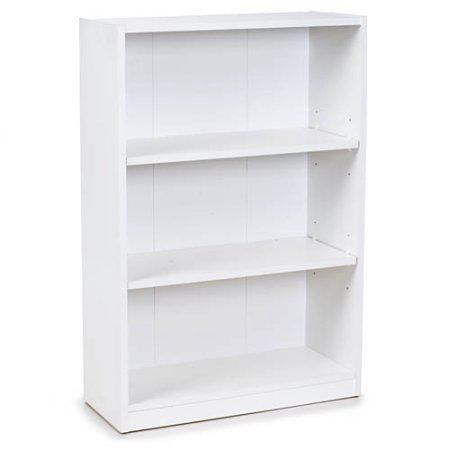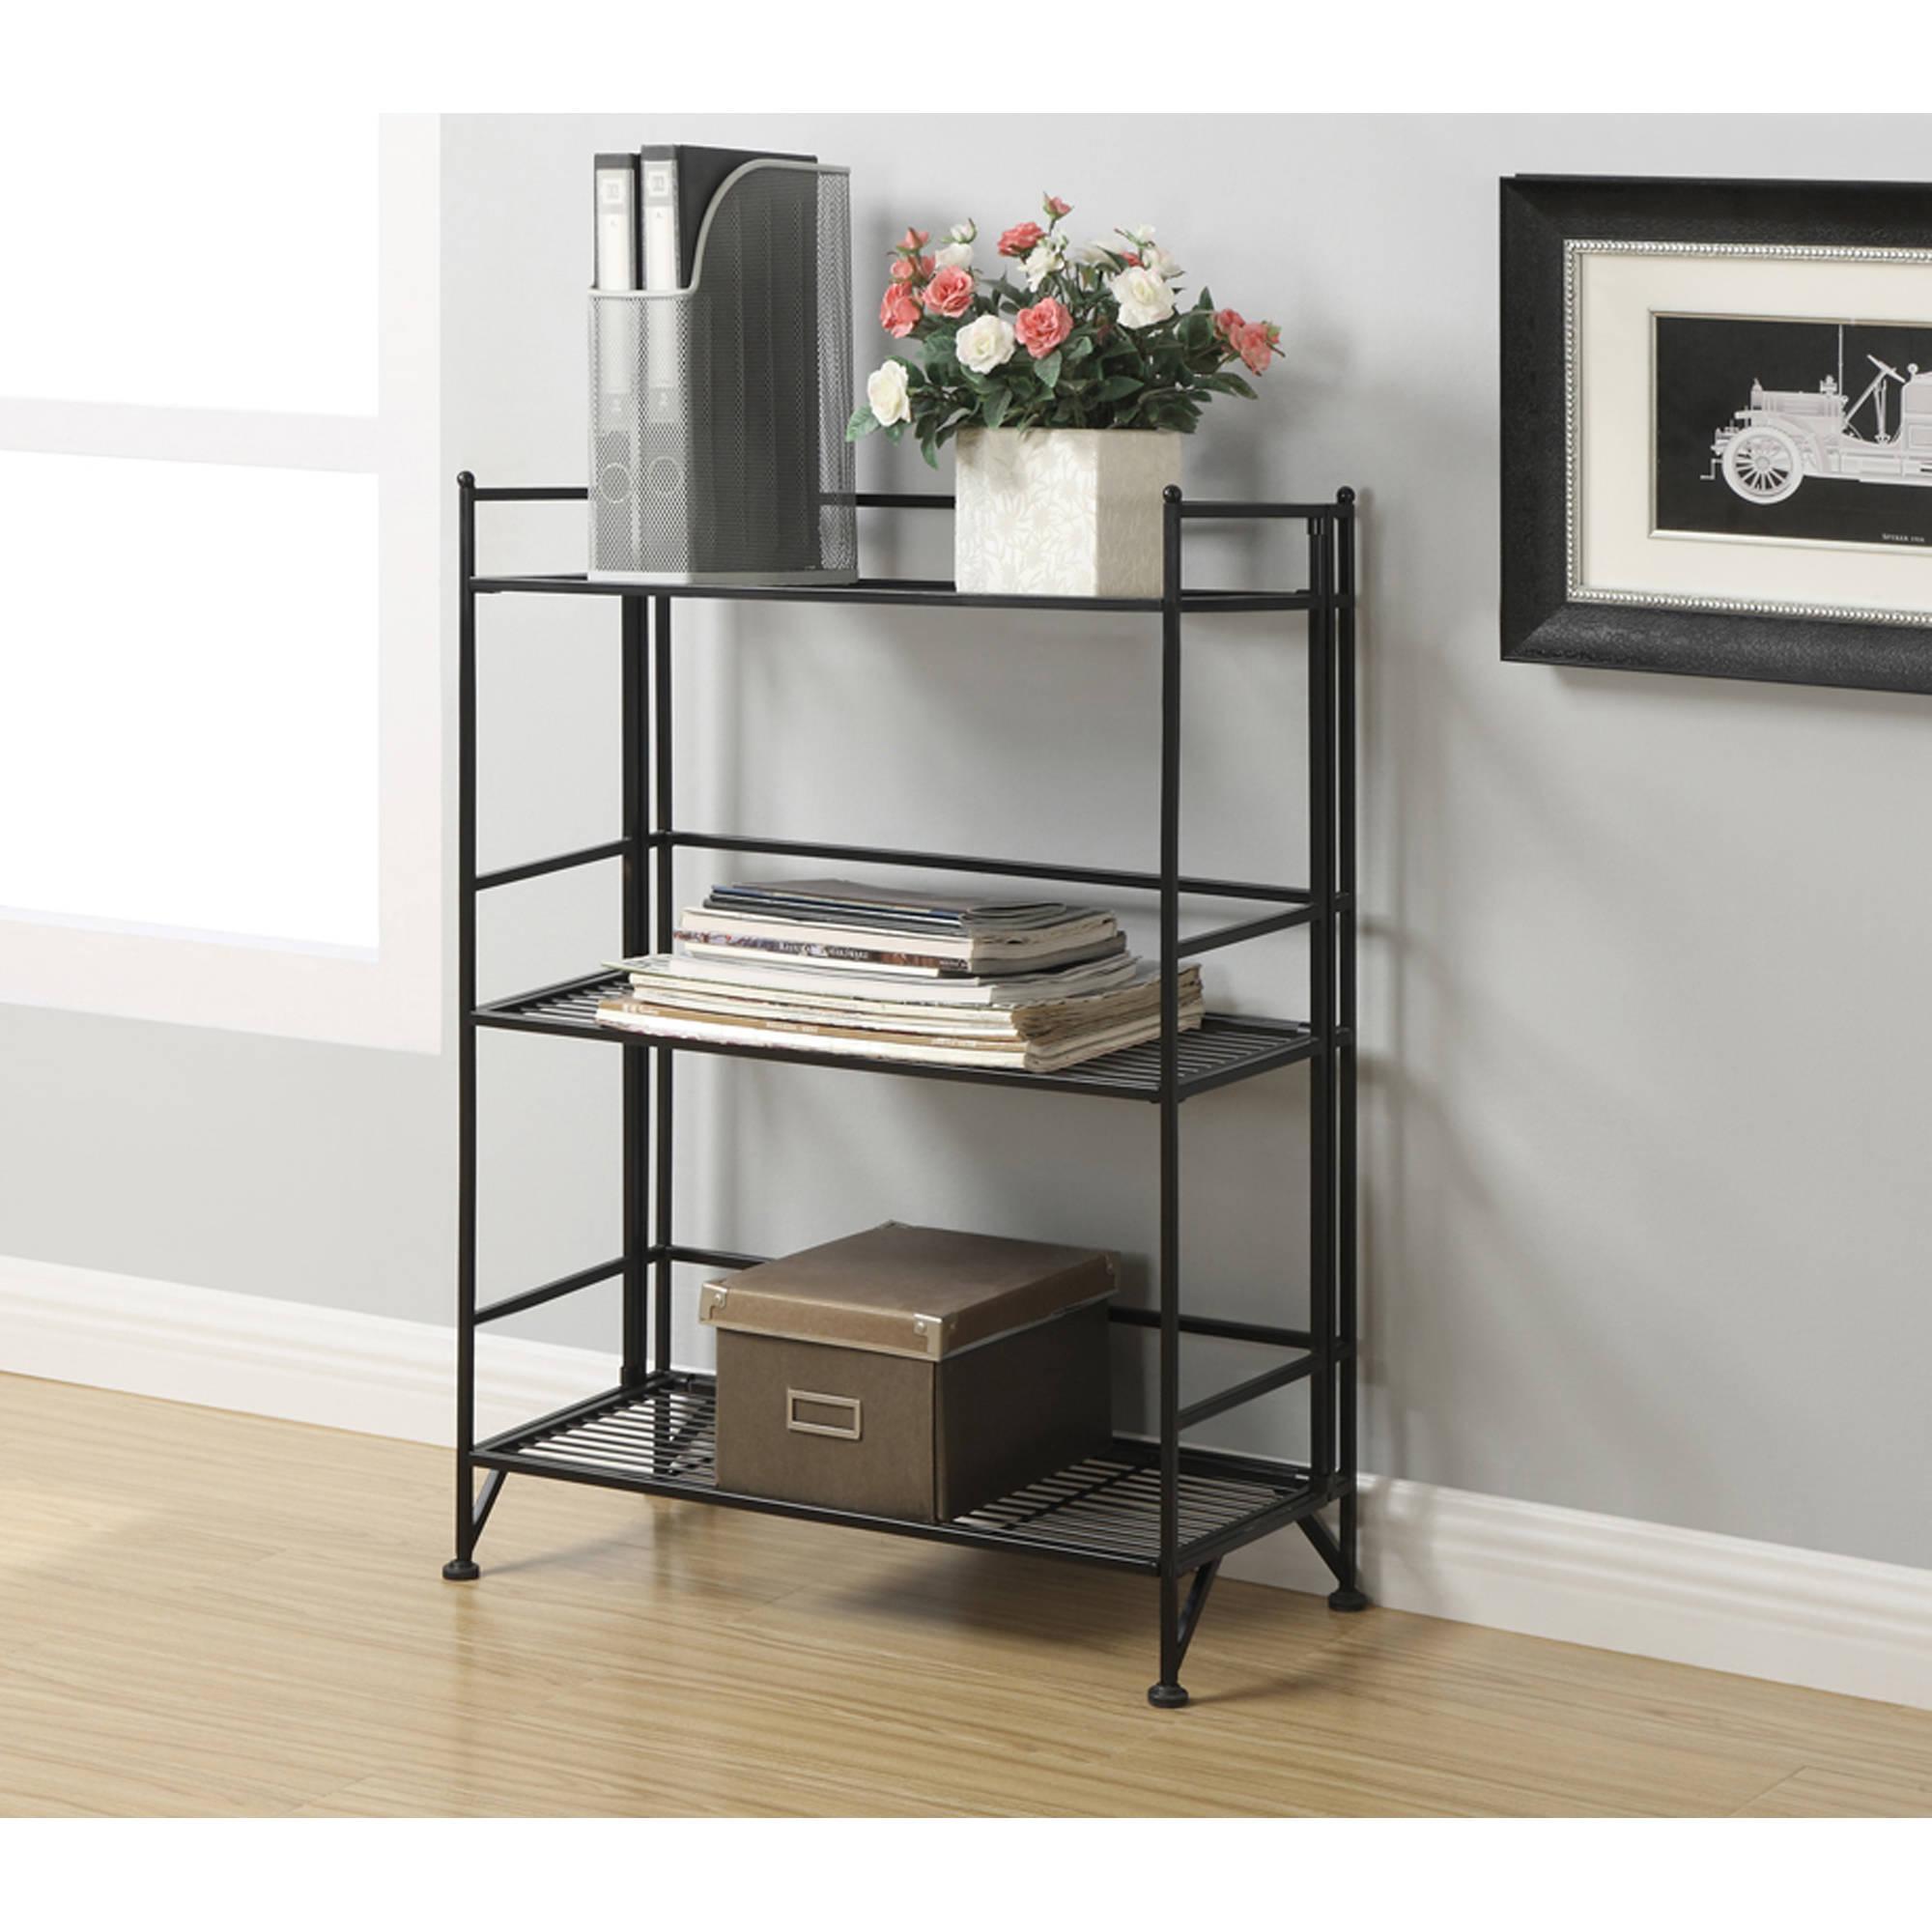The first image is the image on the left, the second image is the image on the right. Assess this claim about the two images: "One of the bookshelves is not white.". Correct or not? Answer yes or no. Yes. The first image is the image on the left, the second image is the image on the right. Considering the images on both sides, is "All shelf units shown are white, and all shelf units contain some books on some shelves." valid? Answer yes or no. No. 